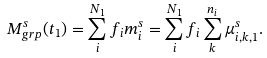Convert formula to latex. <formula><loc_0><loc_0><loc_500><loc_500>M _ { g r p } ^ { s } ( t _ { 1 } ) = \sum _ { i } ^ { N _ { 1 } } f _ { i } m _ { i } ^ { s } = \sum _ { i } ^ { N _ { 1 } } f _ { i } \sum _ { k } ^ { n _ { i } } \mu _ { i , k , 1 } ^ { s } .</formula> 